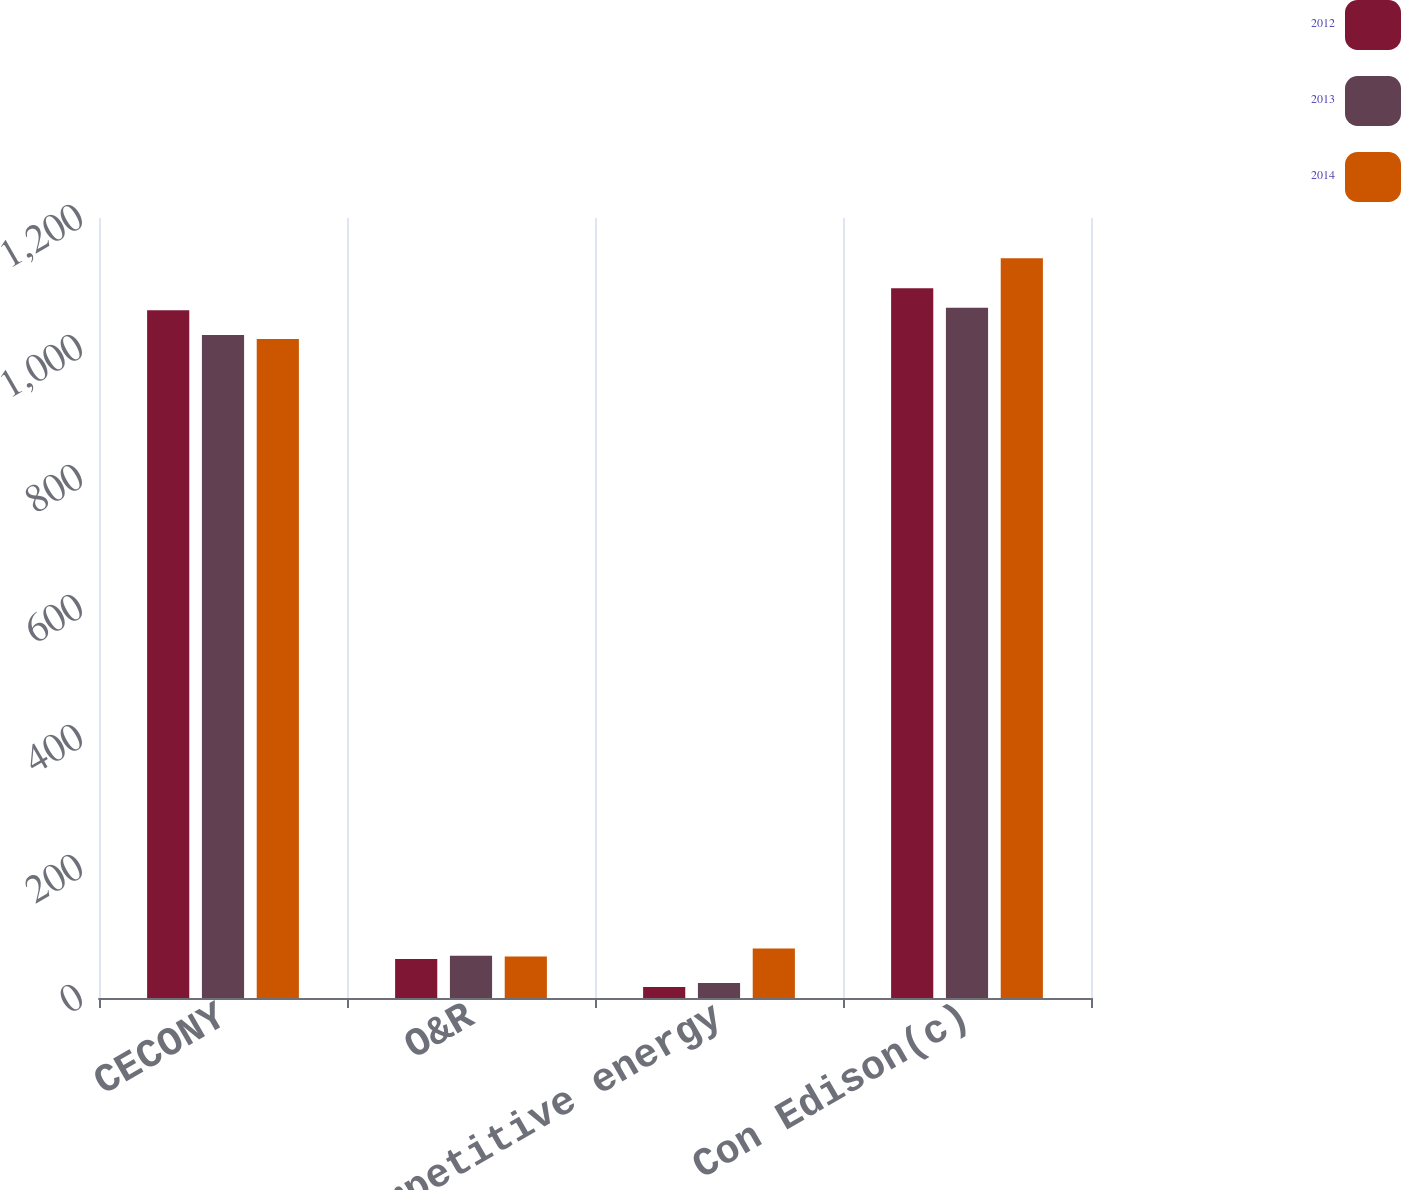<chart> <loc_0><loc_0><loc_500><loc_500><stacked_bar_chart><ecel><fcel>CECONY<fcel>O&R<fcel>Competitive energy<fcel>Con Edison(c)<nl><fcel>2012<fcel>1058<fcel>60<fcel>17<fcel>1092<nl><fcel>2013<fcel>1020<fcel>65<fcel>23<fcel>1062<nl><fcel>2014<fcel>1014<fcel>64<fcel>76<fcel>1138<nl></chart> 